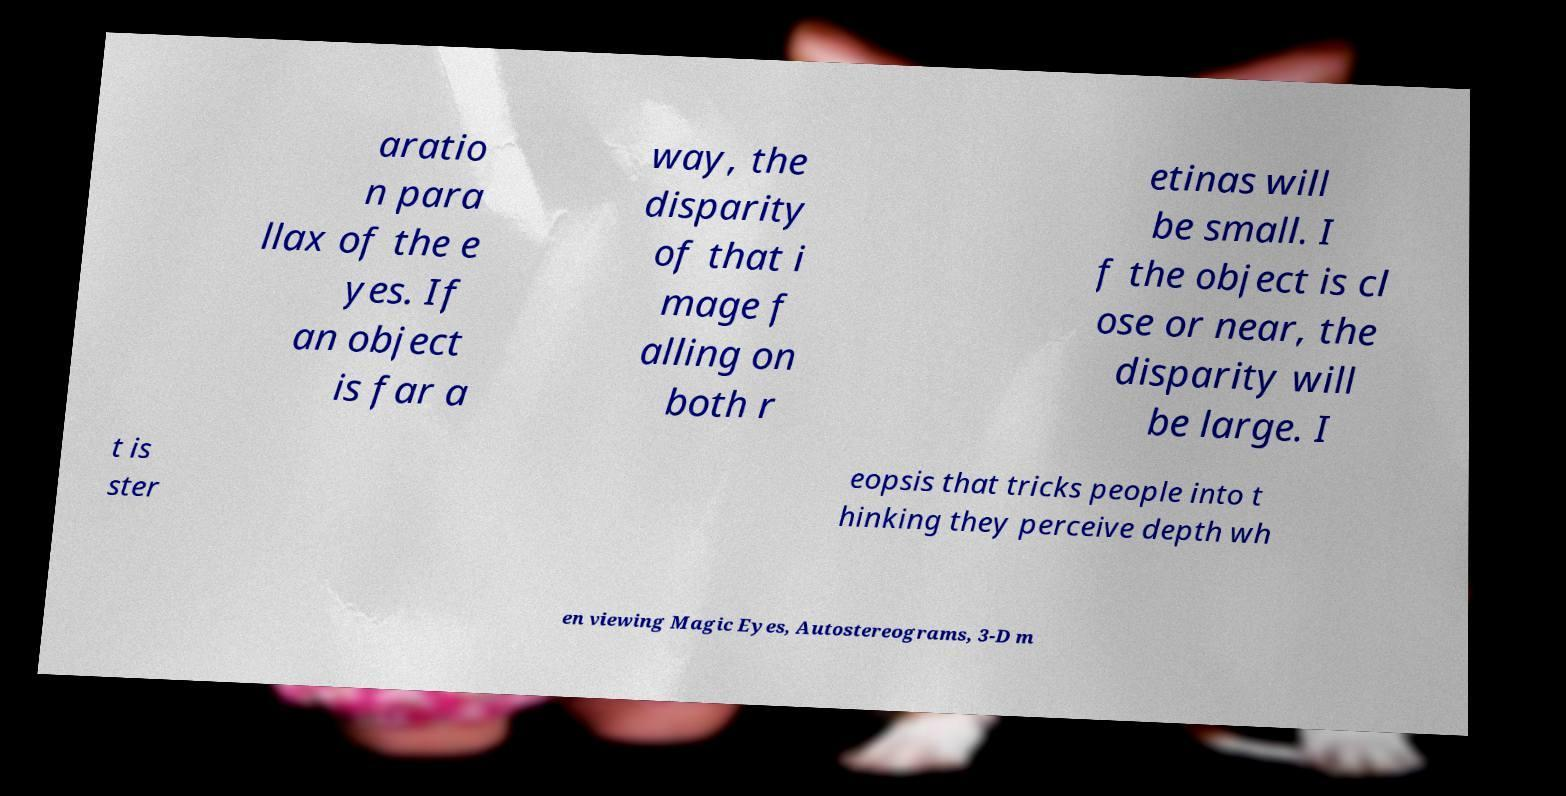For documentation purposes, I need the text within this image transcribed. Could you provide that? aratio n para llax of the e yes. If an object is far a way, the disparity of that i mage f alling on both r etinas will be small. I f the object is cl ose or near, the disparity will be large. I t is ster eopsis that tricks people into t hinking they perceive depth wh en viewing Magic Eyes, Autostereograms, 3-D m 